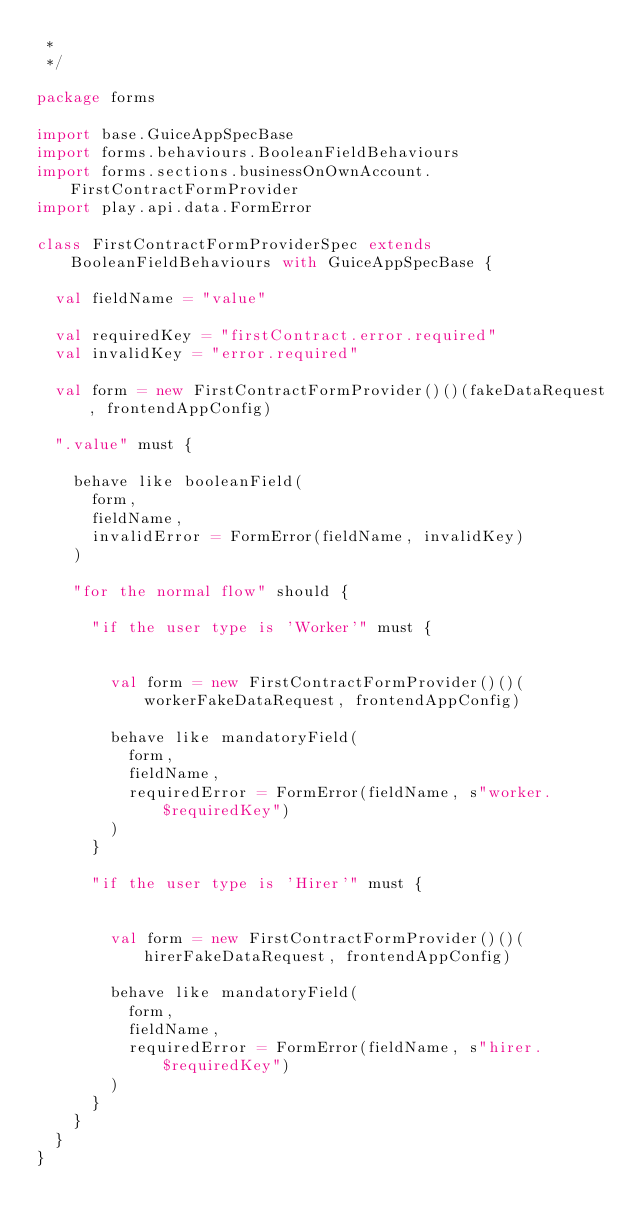Convert code to text. <code><loc_0><loc_0><loc_500><loc_500><_Scala_> *
 */

package forms

import base.GuiceAppSpecBase
import forms.behaviours.BooleanFieldBehaviours
import forms.sections.businessOnOwnAccount.FirstContractFormProvider
import play.api.data.FormError

class FirstContractFormProviderSpec extends BooleanFieldBehaviours with GuiceAppSpecBase {

  val fieldName = "value"

  val requiredKey = "firstContract.error.required"
  val invalidKey = "error.required"

  val form = new FirstContractFormProvider()()(fakeDataRequest, frontendAppConfig)

  ".value" must {

    behave like booleanField(
      form,
      fieldName,
      invalidError = FormError(fieldName, invalidKey)
    )

    "for the normal flow" should {

      "if the user type is 'Worker'" must {


        val form = new FirstContractFormProvider()()(workerFakeDataRequest, frontendAppConfig)

        behave like mandatoryField(
          form,
          fieldName,
          requiredError = FormError(fieldName, s"worker.$requiredKey")
        )
      }

      "if the user type is 'Hirer'" must {


        val form = new FirstContractFormProvider()()(hirerFakeDataRequest, frontendAppConfig)

        behave like mandatoryField(
          form,
          fieldName,
          requiredError = FormError(fieldName, s"hirer.$requiredKey")
        )
      }
    }
  }
}
</code> 